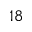<formula> <loc_0><loc_0><loc_500><loc_500>^ { 1 8 }</formula> 